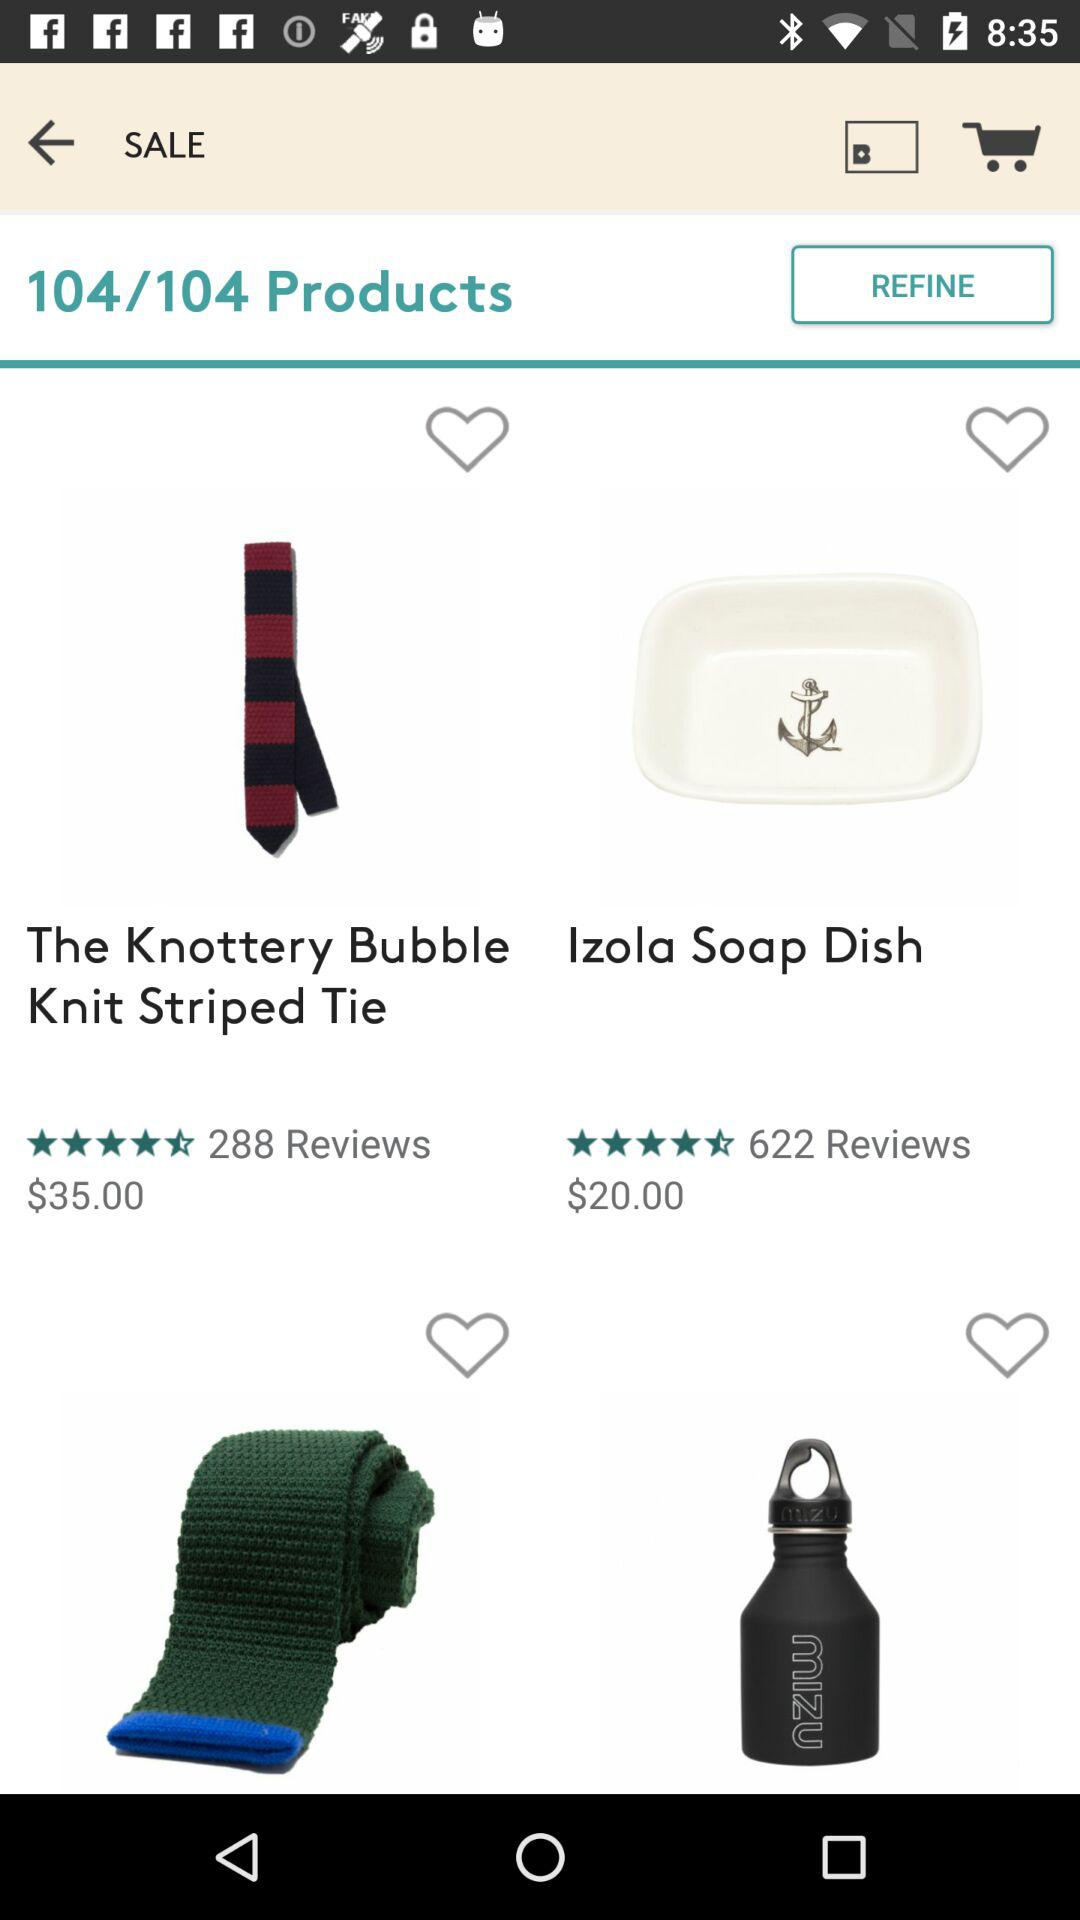What are the total number of products on the screen? The total number of products on the screen is 104. 